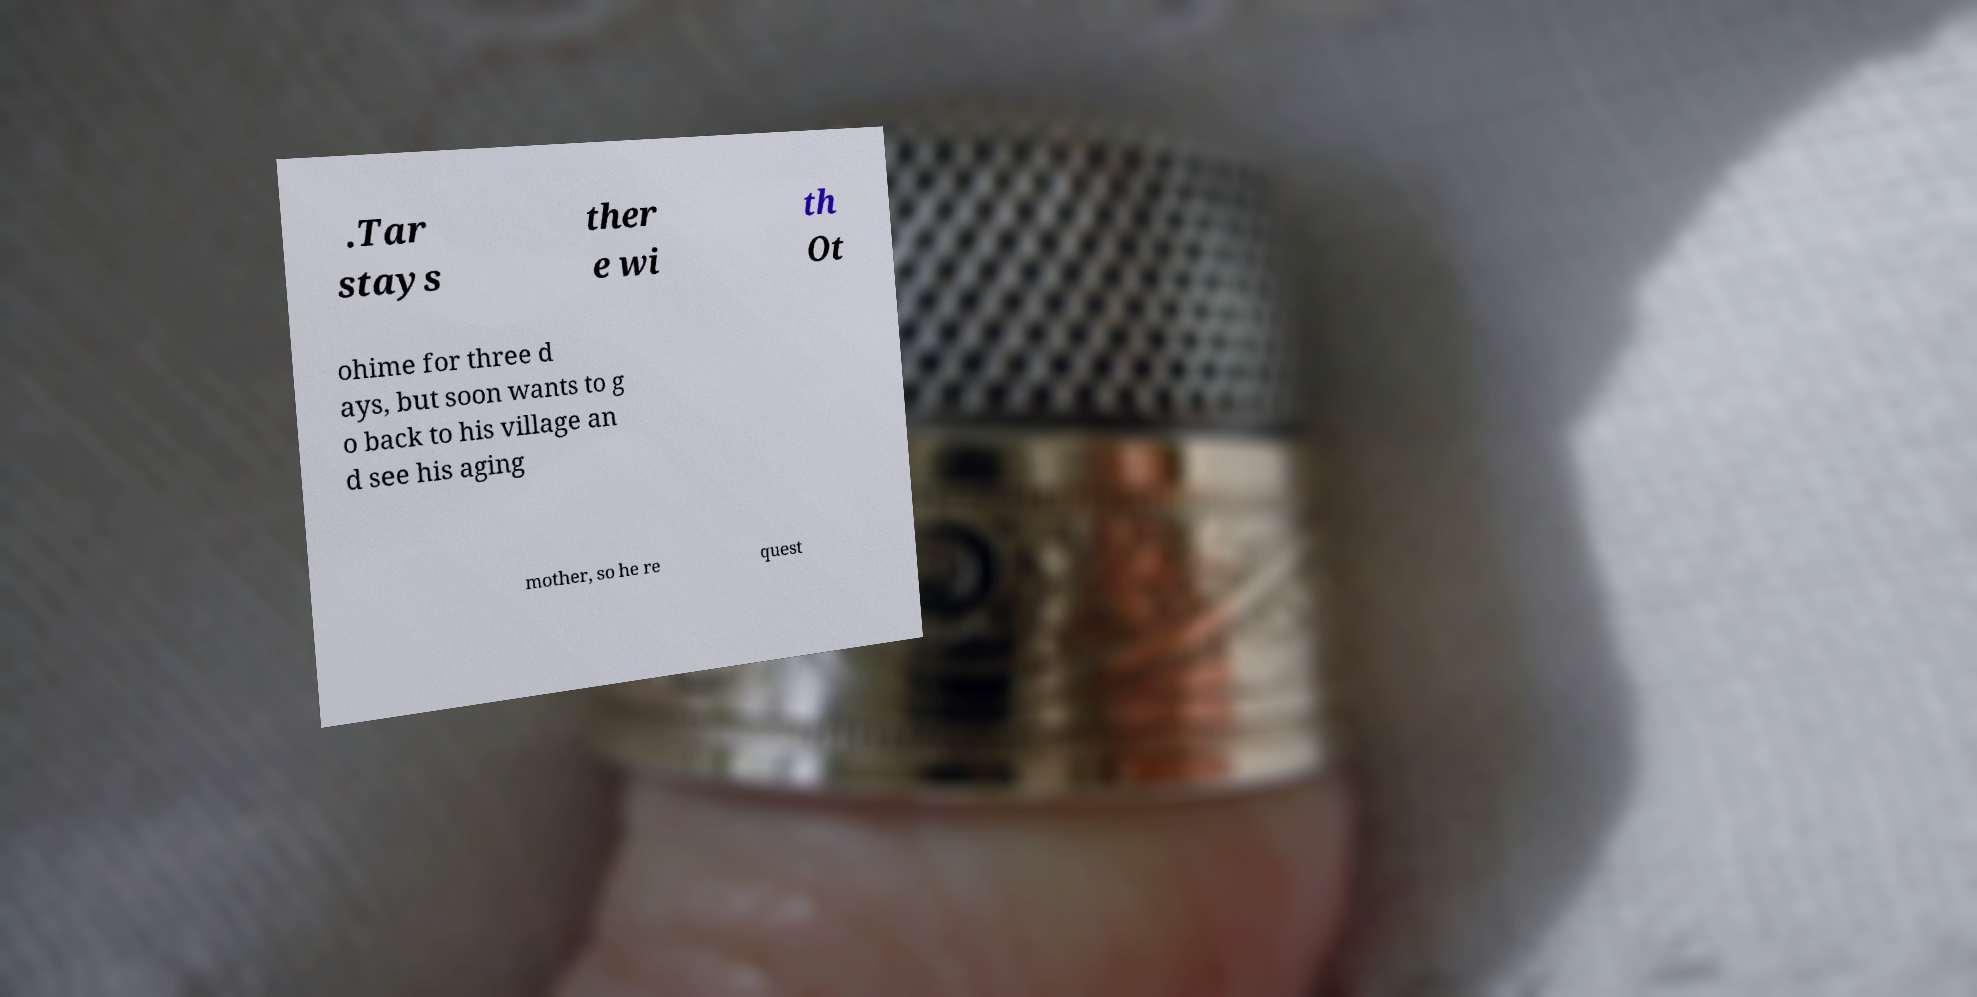Could you extract and type out the text from this image? .Tar stays ther e wi th Ot ohime for three d ays, but soon wants to g o back to his village an d see his aging mother, so he re quest 